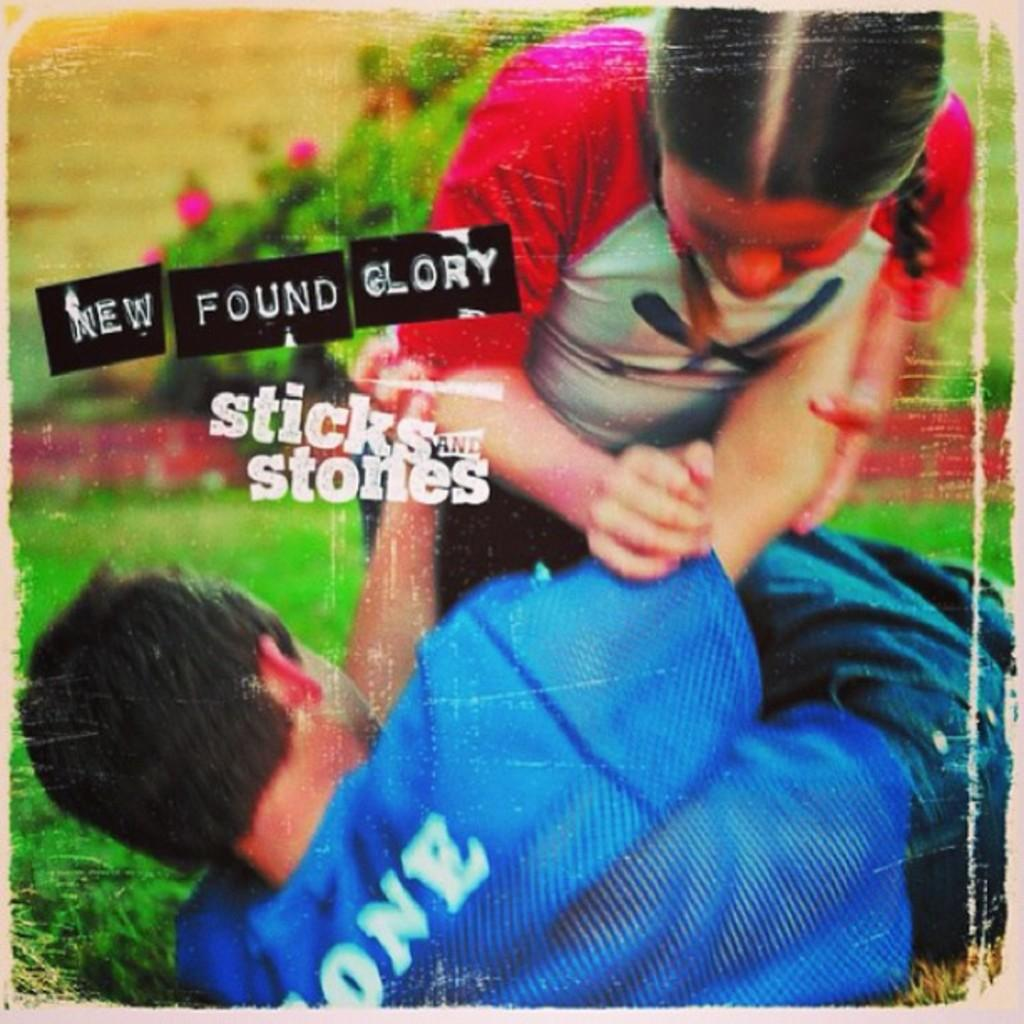How many people are in the image? There are two people in the image. What are the two people doing? The two people are engaged in fighting. What type of terrain is visible in the image? There is grass visible in the image. Are there any identifiable logos in the image? Yes, there are logos present in the image. What color is the balloon that the people are holding in the image? There is no balloon present in the image; the two people are engaged in fighting. How does the mind of the person in the image affect their fighting style? The image does not provide any information about the mental state or thoughts of the people involved in the fight, so it is impossible to determine how their minds might affect their fighting style. 